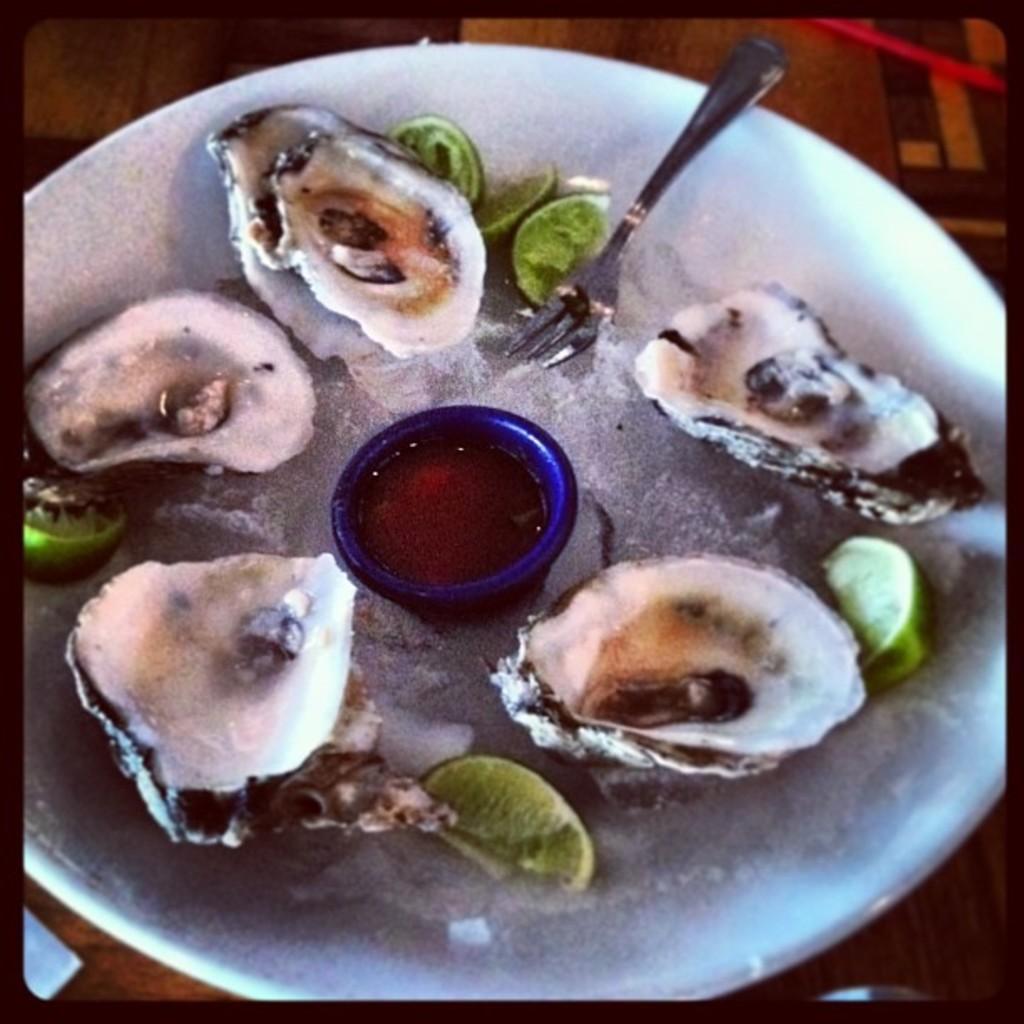Describe this image in one or two sentences. In this image we can see a plate containing shells, lemon slices, fork and a cup placed on the surface. 